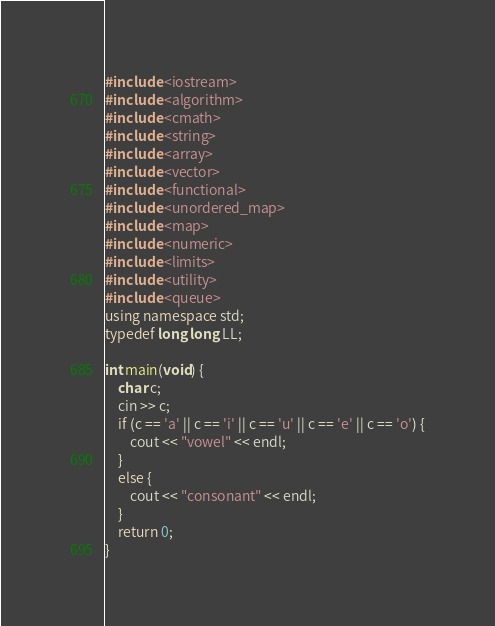Convert code to text. <code><loc_0><loc_0><loc_500><loc_500><_C++_>#include <iostream>
#include <algorithm>
#include <cmath>
#include <string>
#include <array>
#include <vector>
#include <functional>
#include <unordered_map> 
#include <map> 
#include <numeric>
#include <limits>
#include <utility>
#include <queue>
using namespace std;
typedef long long LL;

int main(void) {
	char c;
	cin >> c;
	if (c == 'a' || c == 'i' || c == 'u' || c == 'e' || c == 'o') {
		cout << "vowel" << endl;
	}
	else {
		cout << "consonant" << endl;
	}
	return 0;
}</code> 